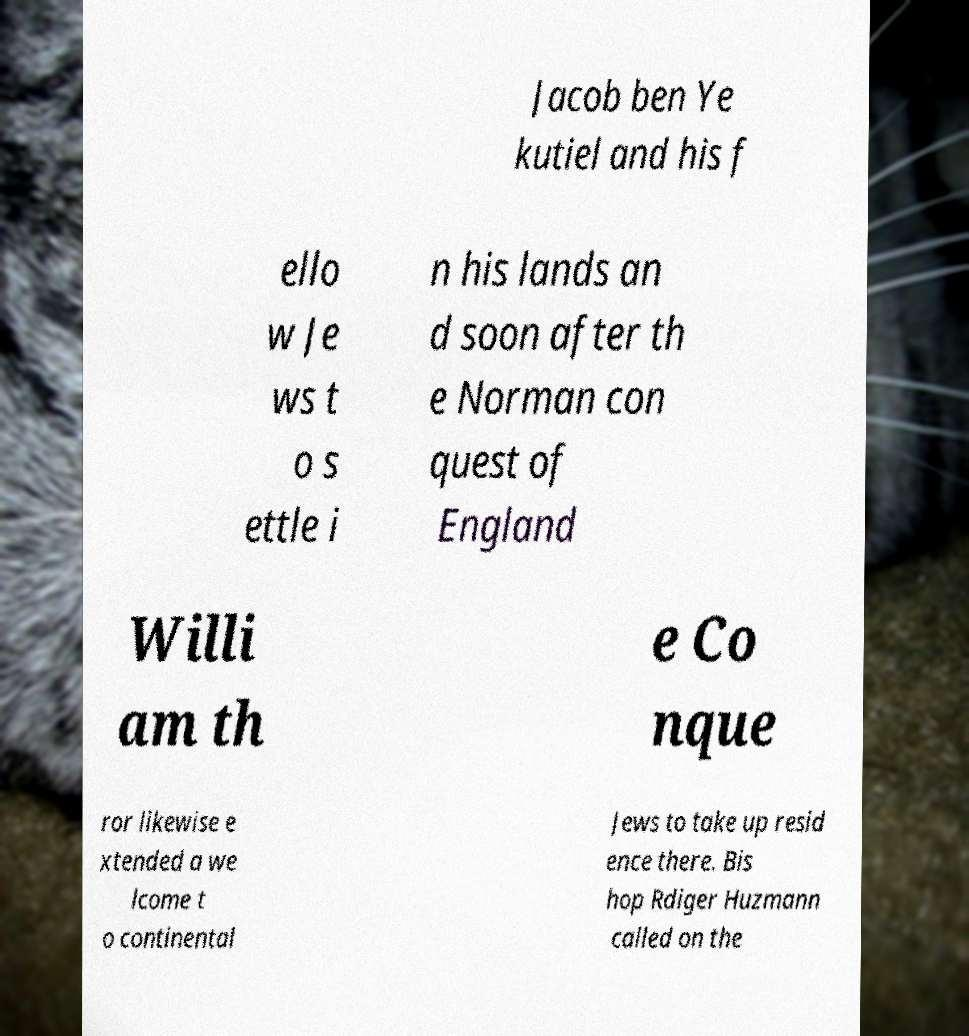Could you assist in decoding the text presented in this image and type it out clearly? Jacob ben Ye kutiel and his f ello w Je ws t o s ettle i n his lands an d soon after th e Norman con quest of England Willi am th e Co nque ror likewise e xtended a we lcome t o continental Jews to take up resid ence there. Bis hop Rdiger Huzmann called on the 